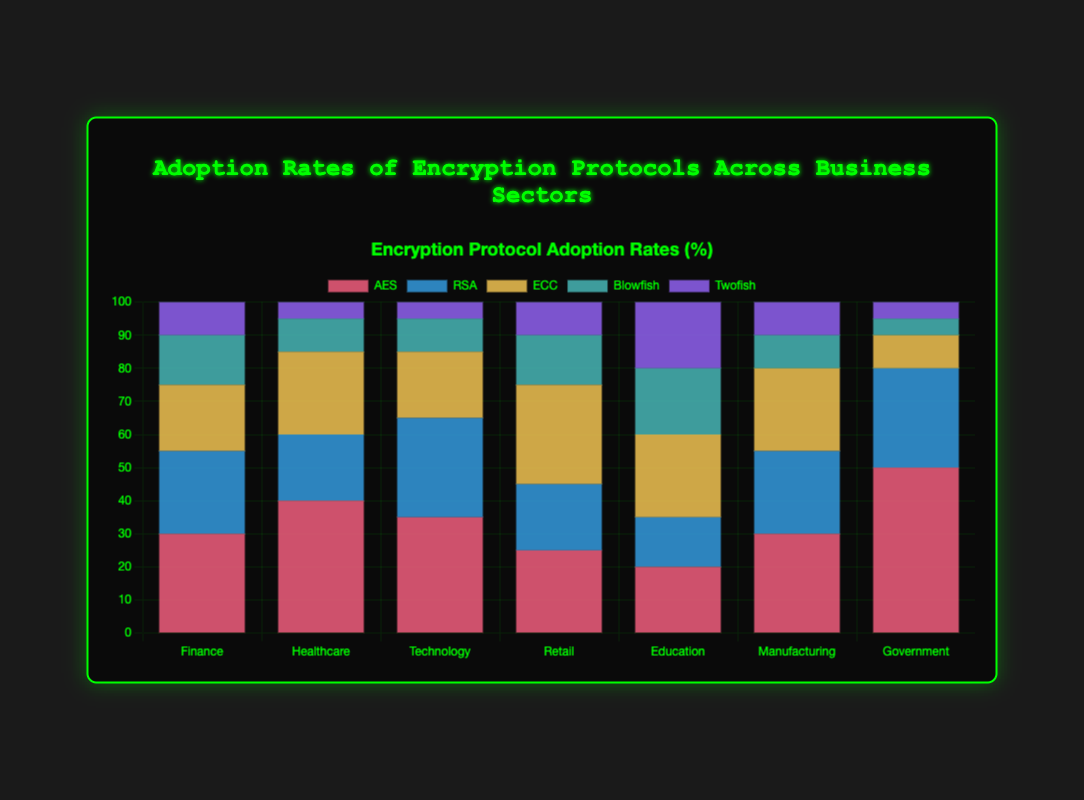What is the most adopted encryption protocol in the Finance sector? The financial sector has five different encryption protocols. Comparing their values, AES has the highest adoption rate with 30%.
Answer: AES Which business sector has the highest adoption rate of RSA? By comparing the RSA values across all sectors: Finance (25%), Healthcare (20%), Technology (30%), Retail (20%), Education (15%), Manufacturing (25%), Government (30%), the Government and Technology sectors both have the highest RSA adoption rate with 30% each.
Answer: Government, Technology In which sector is the adoption rate of Twofish the lowest? Twofish adoption rates across sectors are: Finance (10%), Healthcare (5%), Technology (5%), Retail (10%), Education (20%), Manufacturing (10%), Government (5%). The sectors with the lowest adoption rates are Healthcare, Technology, and Government with 5% each.
Answer: Healthcare, Technology, Government What's the total percentage of AES and RSA adoption in the Healthcare sector? The adoption rates of AES and RSA in Healthcare are 40% and 20% respectively. Adding them together: 40% + 20% = 60%.
Answer: 60% How does the ECC adoption rate in Technology compare to that in Retail? In the Technology sector, ECC adoption is 20%, and in the Retail sector, it is 30%. Comparing the two, the Retail sector has a higher adoption rate of ECC.
Answer: Retail has higher ECC adoption What is the difference between the Blowfish adoption rates in Education and Government? The Blowfish adoption rates are 20% in Education and 5% in Government. The difference is calculated as 20% - 5% = 15%.
Answer: 15% Which encryption protocol has the least variation in adoption rates across all sectors? To determine the least variation, observe the range of values for each protocol across all sectors. Blowfish adoption ranges from 5% to 20%, which is a range of 15%. This is the smallest range compared to the others.
Answer: Blowfish What is the combined adoption rate of ECC, Blowfish, and Twofish in the Manufacturing sector? In Manufacturing, ECC adoption is 25%, Blowfish is 10%, and Twofish is 10%. Adding these together: 25% + 10% + 10% = 45%.
Answer: 45% Which sector predominantly uses AES compared to the other encryption protocols? Comparing the AES values in all sectors and evaluating AES domination: Finance (30%), Healthcare (40%), Technology (35%), Retail (25%), Education (20%), Manufacturing (30%), Government (50%). The Government sector predominantly uses AES with the highest adoption rate of 50%.
Answer: Government 